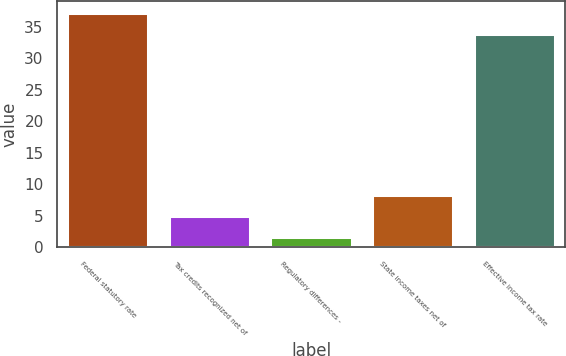<chart> <loc_0><loc_0><loc_500><loc_500><bar_chart><fcel>Federal statutory rate<fcel>Tax credits recognized net of<fcel>Regulatory differences -<fcel>State income taxes net of<fcel>Effective income tax rate<nl><fcel>37.14<fcel>4.94<fcel>1.6<fcel>8.28<fcel>33.8<nl></chart> 